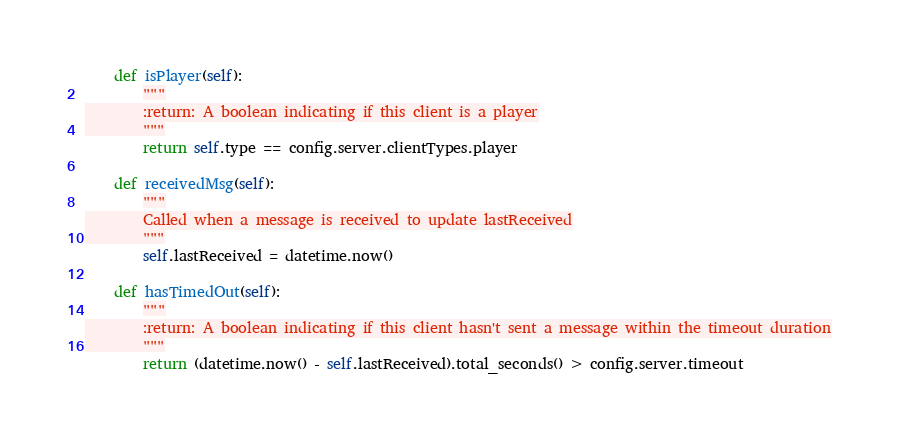<code> <loc_0><loc_0><loc_500><loc_500><_Python_>    def isPlayer(self):
        """
        :return: A boolean indicating if this client is a player
        """
        return self.type == config.server.clientTypes.player

    def receivedMsg(self):
        """
        Called when a message is received to update lastReceived
        """
        self.lastReceived = datetime.now()

    def hasTimedOut(self):
        """
        :return: A boolean indicating if this client hasn't sent a message within the timeout duration
        """
        return (datetime.now() - self.lastReceived).total_seconds() > config.server.timeout</code> 